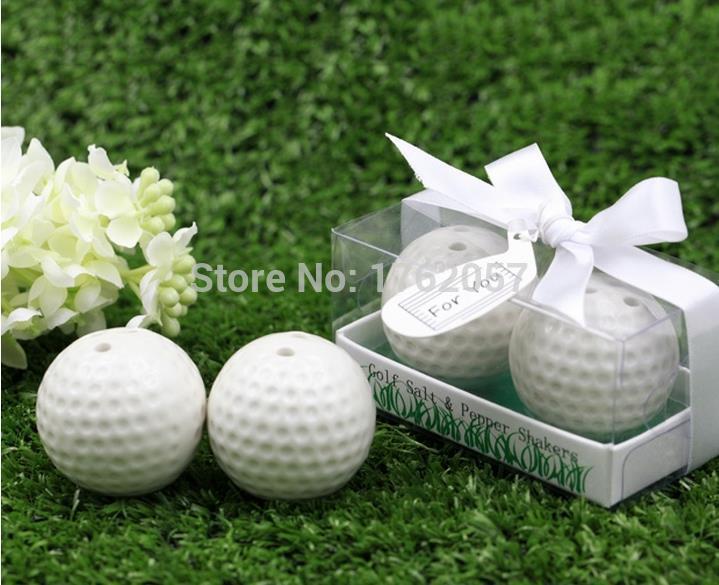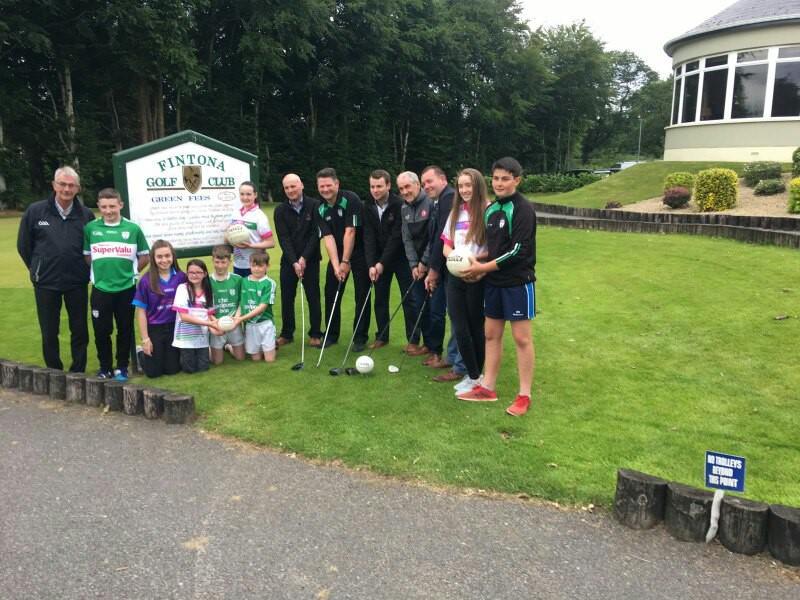The first image is the image on the left, the second image is the image on the right. For the images shown, is this caption "One image shows gift wrapped golf balls." true? Answer yes or no. Yes. The first image is the image on the left, the second image is the image on the right. Evaluate the accuracy of this statement regarding the images: "Multiple people are standing on green grass in one of the golf-themed images.". Is it true? Answer yes or no. Yes. 